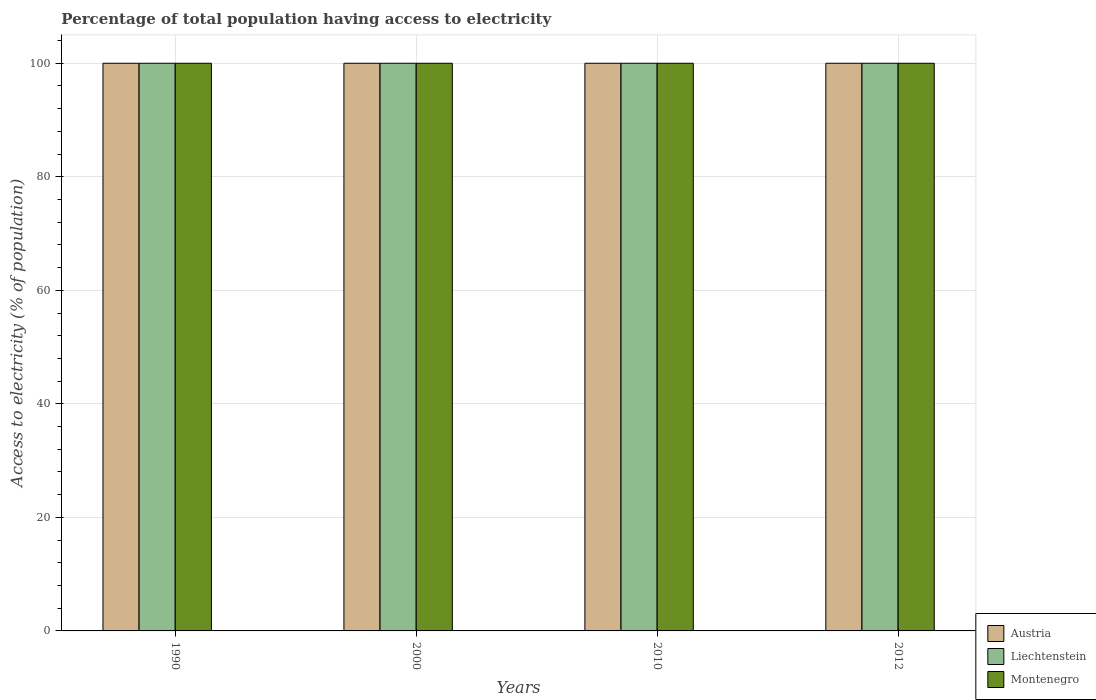How many different coloured bars are there?
Keep it short and to the point. 3. How many groups of bars are there?
Your response must be concise. 4. Are the number of bars per tick equal to the number of legend labels?
Keep it short and to the point. Yes. Are the number of bars on each tick of the X-axis equal?
Keep it short and to the point. Yes. How many bars are there on the 3rd tick from the right?
Your response must be concise. 3. In how many cases, is the number of bars for a given year not equal to the number of legend labels?
Offer a terse response. 0. What is the percentage of population that have access to electricity in Austria in 2000?
Your answer should be very brief. 100. Across all years, what is the maximum percentage of population that have access to electricity in Austria?
Provide a succinct answer. 100. Across all years, what is the minimum percentage of population that have access to electricity in Austria?
Your response must be concise. 100. What is the total percentage of population that have access to electricity in Montenegro in the graph?
Give a very brief answer. 400. What is the difference between the percentage of population that have access to electricity in Austria in 2000 and that in 2012?
Give a very brief answer. 0. What is the difference between the percentage of population that have access to electricity in Austria in 2000 and the percentage of population that have access to electricity in Montenegro in 2012?
Provide a succinct answer. 0. In how many years, is the percentage of population that have access to electricity in Austria greater than 8 %?
Keep it short and to the point. 4. What is the ratio of the percentage of population that have access to electricity in Liechtenstein in 1990 to that in 2012?
Provide a short and direct response. 1. Is the percentage of population that have access to electricity in Austria in 2000 less than that in 2010?
Offer a very short reply. No. Is the difference between the percentage of population that have access to electricity in Austria in 1990 and 2012 greater than the difference between the percentage of population that have access to electricity in Montenegro in 1990 and 2012?
Provide a short and direct response. No. Is the sum of the percentage of population that have access to electricity in Liechtenstein in 1990 and 2010 greater than the maximum percentage of population that have access to electricity in Montenegro across all years?
Make the answer very short. Yes. What does the 3rd bar from the left in 2010 represents?
Keep it short and to the point. Montenegro. What does the 2nd bar from the right in 2000 represents?
Keep it short and to the point. Liechtenstein. Is it the case that in every year, the sum of the percentage of population that have access to electricity in Austria and percentage of population that have access to electricity in Liechtenstein is greater than the percentage of population that have access to electricity in Montenegro?
Your answer should be very brief. Yes. How many bars are there?
Your answer should be very brief. 12. How many years are there in the graph?
Keep it short and to the point. 4. Are the values on the major ticks of Y-axis written in scientific E-notation?
Offer a terse response. No. Does the graph contain any zero values?
Make the answer very short. No. Does the graph contain grids?
Ensure brevity in your answer.  Yes. Where does the legend appear in the graph?
Provide a succinct answer. Bottom right. How many legend labels are there?
Provide a short and direct response. 3. What is the title of the graph?
Keep it short and to the point. Percentage of total population having access to electricity. Does "Slovak Republic" appear as one of the legend labels in the graph?
Give a very brief answer. No. What is the label or title of the X-axis?
Provide a succinct answer. Years. What is the label or title of the Y-axis?
Your response must be concise. Access to electricity (% of population). What is the Access to electricity (% of population) in Montenegro in 2000?
Your answer should be very brief. 100. What is the Access to electricity (% of population) in Austria in 2010?
Your answer should be very brief. 100. What is the Access to electricity (% of population) in Montenegro in 2010?
Ensure brevity in your answer.  100. Across all years, what is the maximum Access to electricity (% of population) in Austria?
Ensure brevity in your answer.  100. Across all years, what is the maximum Access to electricity (% of population) of Liechtenstein?
Offer a very short reply. 100. Across all years, what is the minimum Access to electricity (% of population) in Austria?
Your answer should be very brief. 100. Across all years, what is the minimum Access to electricity (% of population) in Liechtenstein?
Your answer should be compact. 100. Across all years, what is the minimum Access to electricity (% of population) in Montenegro?
Your response must be concise. 100. What is the total Access to electricity (% of population) in Austria in the graph?
Keep it short and to the point. 400. What is the total Access to electricity (% of population) of Liechtenstein in the graph?
Your response must be concise. 400. What is the total Access to electricity (% of population) in Montenegro in the graph?
Give a very brief answer. 400. What is the difference between the Access to electricity (% of population) in Austria in 1990 and that in 2000?
Ensure brevity in your answer.  0. What is the difference between the Access to electricity (% of population) of Liechtenstein in 1990 and that in 2000?
Give a very brief answer. 0. What is the difference between the Access to electricity (% of population) of Liechtenstein in 2000 and that in 2010?
Provide a succinct answer. 0. What is the difference between the Access to electricity (% of population) in Montenegro in 2000 and that in 2010?
Give a very brief answer. 0. What is the difference between the Access to electricity (% of population) in Austria in 2000 and that in 2012?
Provide a succinct answer. 0. What is the difference between the Access to electricity (% of population) of Montenegro in 2000 and that in 2012?
Your response must be concise. 0. What is the difference between the Access to electricity (% of population) in Austria in 2010 and that in 2012?
Offer a terse response. 0. What is the difference between the Access to electricity (% of population) of Liechtenstein in 2010 and that in 2012?
Make the answer very short. 0. What is the difference between the Access to electricity (% of population) of Austria in 1990 and the Access to electricity (% of population) of Liechtenstein in 2000?
Give a very brief answer. 0. What is the difference between the Access to electricity (% of population) of Austria in 1990 and the Access to electricity (% of population) of Montenegro in 2000?
Your response must be concise. 0. What is the difference between the Access to electricity (% of population) in Austria in 1990 and the Access to electricity (% of population) in Liechtenstein in 2010?
Make the answer very short. 0. What is the difference between the Access to electricity (% of population) of Austria in 1990 and the Access to electricity (% of population) of Montenegro in 2010?
Ensure brevity in your answer.  0. What is the difference between the Access to electricity (% of population) in Liechtenstein in 1990 and the Access to electricity (% of population) in Montenegro in 2010?
Your response must be concise. 0. What is the difference between the Access to electricity (% of population) in Liechtenstein in 1990 and the Access to electricity (% of population) in Montenegro in 2012?
Make the answer very short. 0. What is the difference between the Access to electricity (% of population) in Austria in 2000 and the Access to electricity (% of population) in Liechtenstein in 2010?
Give a very brief answer. 0. What is the difference between the Access to electricity (% of population) in Austria in 2000 and the Access to electricity (% of population) in Montenegro in 2010?
Make the answer very short. 0. What is the difference between the Access to electricity (% of population) in Liechtenstein in 2000 and the Access to electricity (% of population) in Montenegro in 2010?
Offer a terse response. 0. What is the difference between the Access to electricity (% of population) in Liechtenstein in 2000 and the Access to electricity (% of population) in Montenegro in 2012?
Your response must be concise. 0. What is the difference between the Access to electricity (% of population) in Austria in 2010 and the Access to electricity (% of population) in Liechtenstein in 2012?
Your answer should be compact. 0. What is the average Access to electricity (% of population) of Austria per year?
Your answer should be very brief. 100. In the year 2000, what is the difference between the Access to electricity (% of population) of Austria and Access to electricity (% of population) of Montenegro?
Offer a very short reply. 0. In the year 2010, what is the difference between the Access to electricity (% of population) in Austria and Access to electricity (% of population) in Liechtenstein?
Make the answer very short. 0. In the year 2010, what is the difference between the Access to electricity (% of population) of Austria and Access to electricity (% of population) of Montenegro?
Your response must be concise. 0. In the year 2012, what is the difference between the Access to electricity (% of population) in Austria and Access to electricity (% of population) in Montenegro?
Make the answer very short. 0. What is the ratio of the Access to electricity (% of population) of Austria in 1990 to that in 2000?
Offer a terse response. 1. What is the ratio of the Access to electricity (% of population) in Liechtenstein in 1990 to that in 2000?
Your answer should be compact. 1. What is the ratio of the Access to electricity (% of population) of Montenegro in 1990 to that in 2000?
Your answer should be very brief. 1. What is the ratio of the Access to electricity (% of population) in Austria in 1990 to that in 2010?
Offer a very short reply. 1. What is the ratio of the Access to electricity (% of population) in Montenegro in 1990 to that in 2010?
Your answer should be compact. 1. What is the ratio of the Access to electricity (% of population) in Austria in 1990 to that in 2012?
Offer a terse response. 1. What is the ratio of the Access to electricity (% of population) of Montenegro in 1990 to that in 2012?
Give a very brief answer. 1. What is the ratio of the Access to electricity (% of population) of Liechtenstein in 2000 to that in 2010?
Your answer should be compact. 1. What is the ratio of the Access to electricity (% of population) of Liechtenstein in 2000 to that in 2012?
Provide a short and direct response. 1. What is the ratio of the Access to electricity (% of population) in Austria in 2010 to that in 2012?
Provide a short and direct response. 1. What is the difference between the highest and the second highest Access to electricity (% of population) in Liechtenstein?
Ensure brevity in your answer.  0. What is the difference between the highest and the second highest Access to electricity (% of population) of Montenegro?
Your response must be concise. 0. What is the difference between the highest and the lowest Access to electricity (% of population) in Austria?
Provide a succinct answer. 0. What is the difference between the highest and the lowest Access to electricity (% of population) of Montenegro?
Make the answer very short. 0. 